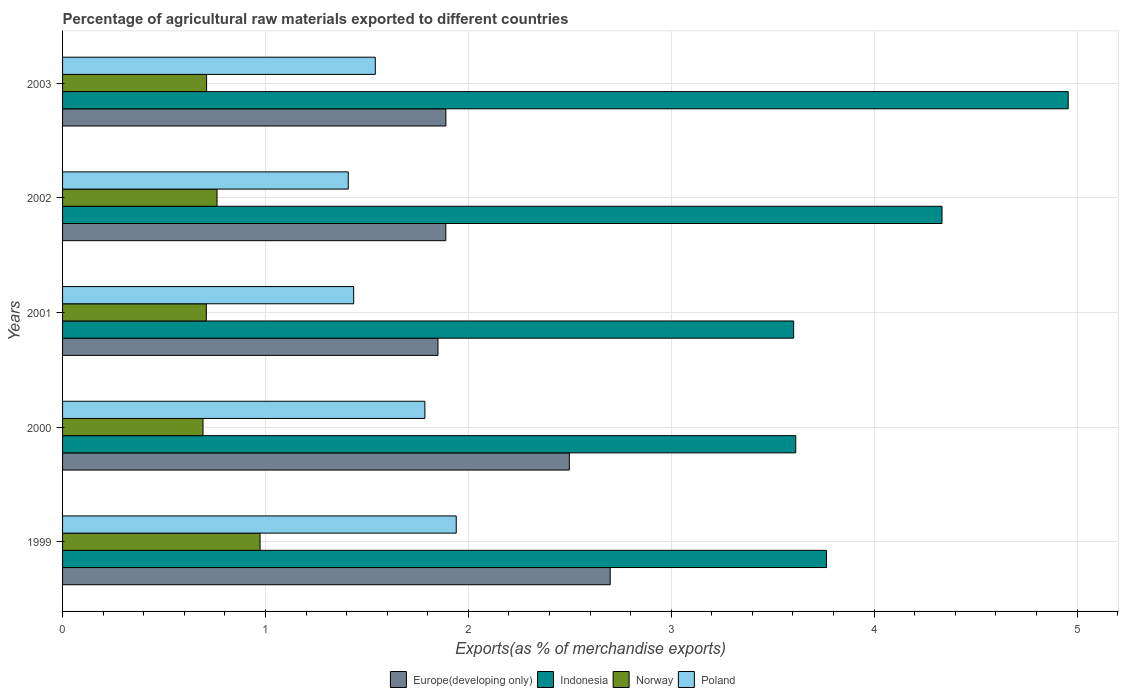How many groups of bars are there?
Give a very brief answer. 5. Are the number of bars per tick equal to the number of legend labels?
Offer a very short reply. Yes. Are the number of bars on each tick of the Y-axis equal?
Make the answer very short. Yes. How many bars are there on the 2nd tick from the top?
Your answer should be very brief. 4. What is the percentage of exports to different countries in Indonesia in 1999?
Offer a very short reply. 3.77. Across all years, what is the maximum percentage of exports to different countries in Norway?
Keep it short and to the point. 0.97. Across all years, what is the minimum percentage of exports to different countries in Poland?
Provide a succinct answer. 1.41. In which year was the percentage of exports to different countries in Indonesia maximum?
Provide a short and direct response. 2003. What is the total percentage of exports to different countries in Indonesia in the graph?
Offer a terse response. 20.27. What is the difference between the percentage of exports to different countries in Norway in 2000 and that in 2003?
Keep it short and to the point. -0.02. What is the difference between the percentage of exports to different countries in Poland in 2003 and the percentage of exports to different countries in Europe(developing only) in 2002?
Provide a short and direct response. -0.35. What is the average percentage of exports to different countries in Poland per year?
Your answer should be compact. 1.62. In the year 1999, what is the difference between the percentage of exports to different countries in Indonesia and percentage of exports to different countries in Poland?
Your answer should be very brief. 1.83. In how many years, is the percentage of exports to different countries in Indonesia greater than 3.2 %?
Offer a terse response. 5. What is the ratio of the percentage of exports to different countries in Norway in 2001 to that in 2003?
Your response must be concise. 1. Is the percentage of exports to different countries in Europe(developing only) in 2001 less than that in 2003?
Provide a succinct answer. Yes. Is the difference between the percentage of exports to different countries in Indonesia in 1999 and 2000 greater than the difference between the percentage of exports to different countries in Poland in 1999 and 2000?
Provide a short and direct response. No. What is the difference between the highest and the second highest percentage of exports to different countries in Europe(developing only)?
Keep it short and to the point. 0.2. What is the difference between the highest and the lowest percentage of exports to different countries in Poland?
Your response must be concise. 0.53. Is the sum of the percentage of exports to different countries in Norway in 2001 and 2002 greater than the maximum percentage of exports to different countries in Indonesia across all years?
Provide a succinct answer. No. Is it the case that in every year, the sum of the percentage of exports to different countries in Norway and percentage of exports to different countries in Europe(developing only) is greater than the sum of percentage of exports to different countries in Indonesia and percentage of exports to different countries in Poland?
Offer a very short reply. No. What does the 3rd bar from the top in 2002 represents?
Your answer should be very brief. Indonesia. How many bars are there?
Provide a succinct answer. 20. Does the graph contain grids?
Your answer should be very brief. Yes. What is the title of the graph?
Your answer should be compact. Percentage of agricultural raw materials exported to different countries. What is the label or title of the X-axis?
Your response must be concise. Exports(as % of merchandise exports). What is the Exports(as % of merchandise exports) in Europe(developing only) in 1999?
Offer a very short reply. 2.7. What is the Exports(as % of merchandise exports) of Indonesia in 1999?
Offer a terse response. 3.77. What is the Exports(as % of merchandise exports) of Norway in 1999?
Keep it short and to the point. 0.97. What is the Exports(as % of merchandise exports) of Poland in 1999?
Keep it short and to the point. 1.94. What is the Exports(as % of merchandise exports) in Europe(developing only) in 2000?
Offer a terse response. 2.5. What is the Exports(as % of merchandise exports) in Indonesia in 2000?
Offer a terse response. 3.61. What is the Exports(as % of merchandise exports) in Norway in 2000?
Give a very brief answer. 0.69. What is the Exports(as % of merchandise exports) of Poland in 2000?
Your answer should be compact. 1.79. What is the Exports(as % of merchandise exports) of Europe(developing only) in 2001?
Keep it short and to the point. 1.85. What is the Exports(as % of merchandise exports) in Indonesia in 2001?
Your answer should be very brief. 3.6. What is the Exports(as % of merchandise exports) of Norway in 2001?
Your answer should be compact. 0.71. What is the Exports(as % of merchandise exports) of Poland in 2001?
Your answer should be very brief. 1.43. What is the Exports(as % of merchandise exports) of Europe(developing only) in 2002?
Keep it short and to the point. 1.89. What is the Exports(as % of merchandise exports) in Indonesia in 2002?
Provide a succinct answer. 4.33. What is the Exports(as % of merchandise exports) of Norway in 2002?
Provide a short and direct response. 0.76. What is the Exports(as % of merchandise exports) of Poland in 2002?
Offer a very short reply. 1.41. What is the Exports(as % of merchandise exports) in Europe(developing only) in 2003?
Your answer should be compact. 1.89. What is the Exports(as % of merchandise exports) in Indonesia in 2003?
Keep it short and to the point. 4.96. What is the Exports(as % of merchandise exports) of Norway in 2003?
Ensure brevity in your answer.  0.71. What is the Exports(as % of merchandise exports) of Poland in 2003?
Offer a terse response. 1.54. Across all years, what is the maximum Exports(as % of merchandise exports) of Europe(developing only)?
Keep it short and to the point. 2.7. Across all years, what is the maximum Exports(as % of merchandise exports) in Indonesia?
Provide a short and direct response. 4.96. Across all years, what is the maximum Exports(as % of merchandise exports) of Norway?
Ensure brevity in your answer.  0.97. Across all years, what is the maximum Exports(as % of merchandise exports) in Poland?
Offer a very short reply. 1.94. Across all years, what is the minimum Exports(as % of merchandise exports) in Europe(developing only)?
Your answer should be compact. 1.85. Across all years, what is the minimum Exports(as % of merchandise exports) in Indonesia?
Offer a terse response. 3.6. Across all years, what is the minimum Exports(as % of merchandise exports) in Norway?
Offer a terse response. 0.69. Across all years, what is the minimum Exports(as % of merchandise exports) of Poland?
Give a very brief answer. 1.41. What is the total Exports(as % of merchandise exports) of Europe(developing only) in the graph?
Offer a terse response. 10.83. What is the total Exports(as % of merchandise exports) in Indonesia in the graph?
Keep it short and to the point. 20.27. What is the total Exports(as % of merchandise exports) in Norway in the graph?
Make the answer very short. 3.85. What is the total Exports(as % of merchandise exports) in Poland in the graph?
Provide a succinct answer. 8.11. What is the difference between the Exports(as % of merchandise exports) in Europe(developing only) in 1999 and that in 2000?
Provide a short and direct response. 0.2. What is the difference between the Exports(as % of merchandise exports) of Indonesia in 1999 and that in 2000?
Offer a terse response. 0.15. What is the difference between the Exports(as % of merchandise exports) of Norway in 1999 and that in 2000?
Ensure brevity in your answer.  0.28. What is the difference between the Exports(as % of merchandise exports) of Poland in 1999 and that in 2000?
Provide a succinct answer. 0.15. What is the difference between the Exports(as % of merchandise exports) in Europe(developing only) in 1999 and that in 2001?
Ensure brevity in your answer.  0.85. What is the difference between the Exports(as % of merchandise exports) in Indonesia in 1999 and that in 2001?
Provide a short and direct response. 0.16. What is the difference between the Exports(as % of merchandise exports) in Norway in 1999 and that in 2001?
Your answer should be very brief. 0.26. What is the difference between the Exports(as % of merchandise exports) in Poland in 1999 and that in 2001?
Give a very brief answer. 0.51. What is the difference between the Exports(as % of merchandise exports) in Europe(developing only) in 1999 and that in 2002?
Offer a very short reply. 0.81. What is the difference between the Exports(as % of merchandise exports) of Indonesia in 1999 and that in 2002?
Provide a succinct answer. -0.57. What is the difference between the Exports(as % of merchandise exports) in Norway in 1999 and that in 2002?
Your answer should be very brief. 0.21. What is the difference between the Exports(as % of merchandise exports) in Poland in 1999 and that in 2002?
Give a very brief answer. 0.53. What is the difference between the Exports(as % of merchandise exports) in Europe(developing only) in 1999 and that in 2003?
Your answer should be compact. 0.81. What is the difference between the Exports(as % of merchandise exports) in Indonesia in 1999 and that in 2003?
Your answer should be compact. -1.19. What is the difference between the Exports(as % of merchandise exports) of Norway in 1999 and that in 2003?
Give a very brief answer. 0.26. What is the difference between the Exports(as % of merchandise exports) of Poland in 1999 and that in 2003?
Ensure brevity in your answer.  0.4. What is the difference between the Exports(as % of merchandise exports) of Europe(developing only) in 2000 and that in 2001?
Ensure brevity in your answer.  0.65. What is the difference between the Exports(as % of merchandise exports) of Indonesia in 2000 and that in 2001?
Make the answer very short. 0.01. What is the difference between the Exports(as % of merchandise exports) of Norway in 2000 and that in 2001?
Ensure brevity in your answer.  -0.02. What is the difference between the Exports(as % of merchandise exports) of Poland in 2000 and that in 2001?
Provide a succinct answer. 0.35. What is the difference between the Exports(as % of merchandise exports) of Europe(developing only) in 2000 and that in 2002?
Make the answer very short. 0.61. What is the difference between the Exports(as % of merchandise exports) in Indonesia in 2000 and that in 2002?
Your response must be concise. -0.72. What is the difference between the Exports(as % of merchandise exports) in Norway in 2000 and that in 2002?
Ensure brevity in your answer.  -0.07. What is the difference between the Exports(as % of merchandise exports) of Poland in 2000 and that in 2002?
Keep it short and to the point. 0.38. What is the difference between the Exports(as % of merchandise exports) in Europe(developing only) in 2000 and that in 2003?
Your answer should be very brief. 0.61. What is the difference between the Exports(as % of merchandise exports) in Indonesia in 2000 and that in 2003?
Your answer should be very brief. -1.34. What is the difference between the Exports(as % of merchandise exports) in Norway in 2000 and that in 2003?
Make the answer very short. -0.02. What is the difference between the Exports(as % of merchandise exports) of Poland in 2000 and that in 2003?
Your answer should be very brief. 0.24. What is the difference between the Exports(as % of merchandise exports) of Europe(developing only) in 2001 and that in 2002?
Ensure brevity in your answer.  -0.04. What is the difference between the Exports(as % of merchandise exports) of Indonesia in 2001 and that in 2002?
Provide a succinct answer. -0.73. What is the difference between the Exports(as % of merchandise exports) of Norway in 2001 and that in 2002?
Keep it short and to the point. -0.05. What is the difference between the Exports(as % of merchandise exports) in Poland in 2001 and that in 2002?
Your answer should be compact. 0.03. What is the difference between the Exports(as % of merchandise exports) in Europe(developing only) in 2001 and that in 2003?
Offer a very short reply. -0.04. What is the difference between the Exports(as % of merchandise exports) of Indonesia in 2001 and that in 2003?
Give a very brief answer. -1.35. What is the difference between the Exports(as % of merchandise exports) in Norway in 2001 and that in 2003?
Offer a terse response. -0. What is the difference between the Exports(as % of merchandise exports) of Poland in 2001 and that in 2003?
Provide a short and direct response. -0.11. What is the difference between the Exports(as % of merchandise exports) in Europe(developing only) in 2002 and that in 2003?
Keep it short and to the point. -0. What is the difference between the Exports(as % of merchandise exports) in Indonesia in 2002 and that in 2003?
Provide a short and direct response. -0.62. What is the difference between the Exports(as % of merchandise exports) of Norway in 2002 and that in 2003?
Make the answer very short. 0.05. What is the difference between the Exports(as % of merchandise exports) of Poland in 2002 and that in 2003?
Provide a short and direct response. -0.13. What is the difference between the Exports(as % of merchandise exports) of Europe(developing only) in 1999 and the Exports(as % of merchandise exports) of Indonesia in 2000?
Offer a very short reply. -0.91. What is the difference between the Exports(as % of merchandise exports) in Europe(developing only) in 1999 and the Exports(as % of merchandise exports) in Norway in 2000?
Your answer should be compact. 2.01. What is the difference between the Exports(as % of merchandise exports) in Europe(developing only) in 1999 and the Exports(as % of merchandise exports) in Poland in 2000?
Your answer should be very brief. 0.91. What is the difference between the Exports(as % of merchandise exports) of Indonesia in 1999 and the Exports(as % of merchandise exports) of Norway in 2000?
Your answer should be very brief. 3.07. What is the difference between the Exports(as % of merchandise exports) of Indonesia in 1999 and the Exports(as % of merchandise exports) of Poland in 2000?
Provide a succinct answer. 1.98. What is the difference between the Exports(as % of merchandise exports) in Norway in 1999 and the Exports(as % of merchandise exports) in Poland in 2000?
Make the answer very short. -0.81. What is the difference between the Exports(as % of merchandise exports) of Europe(developing only) in 1999 and the Exports(as % of merchandise exports) of Indonesia in 2001?
Your answer should be very brief. -0.9. What is the difference between the Exports(as % of merchandise exports) in Europe(developing only) in 1999 and the Exports(as % of merchandise exports) in Norway in 2001?
Provide a short and direct response. 1.99. What is the difference between the Exports(as % of merchandise exports) in Europe(developing only) in 1999 and the Exports(as % of merchandise exports) in Poland in 2001?
Make the answer very short. 1.26. What is the difference between the Exports(as % of merchandise exports) in Indonesia in 1999 and the Exports(as % of merchandise exports) in Norway in 2001?
Keep it short and to the point. 3.06. What is the difference between the Exports(as % of merchandise exports) in Indonesia in 1999 and the Exports(as % of merchandise exports) in Poland in 2001?
Keep it short and to the point. 2.33. What is the difference between the Exports(as % of merchandise exports) of Norway in 1999 and the Exports(as % of merchandise exports) of Poland in 2001?
Your response must be concise. -0.46. What is the difference between the Exports(as % of merchandise exports) in Europe(developing only) in 1999 and the Exports(as % of merchandise exports) in Indonesia in 2002?
Your answer should be very brief. -1.64. What is the difference between the Exports(as % of merchandise exports) of Europe(developing only) in 1999 and the Exports(as % of merchandise exports) of Norway in 2002?
Provide a succinct answer. 1.94. What is the difference between the Exports(as % of merchandise exports) in Europe(developing only) in 1999 and the Exports(as % of merchandise exports) in Poland in 2002?
Your answer should be very brief. 1.29. What is the difference between the Exports(as % of merchandise exports) in Indonesia in 1999 and the Exports(as % of merchandise exports) in Norway in 2002?
Keep it short and to the point. 3. What is the difference between the Exports(as % of merchandise exports) of Indonesia in 1999 and the Exports(as % of merchandise exports) of Poland in 2002?
Ensure brevity in your answer.  2.36. What is the difference between the Exports(as % of merchandise exports) in Norway in 1999 and the Exports(as % of merchandise exports) in Poland in 2002?
Your response must be concise. -0.43. What is the difference between the Exports(as % of merchandise exports) in Europe(developing only) in 1999 and the Exports(as % of merchandise exports) in Indonesia in 2003?
Offer a very short reply. -2.26. What is the difference between the Exports(as % of merchandise exports) in Europe(developing only) in 1999 and the Exports(as % of merchandise exports) in Norway in 2003?
Your answer should be very brief. 1.99. What is the difference between the Exports(as % of merchandise exports) in Europe(developing only) in 1999 and the Exports(as % of merchandise exports) in Poland in 2003?
Keep it short and to the point. 1.16. What is the difference between the Exports(as % of merchandise exports) of Indonesia in 1999 and the Exports(as % of merchandise exports) of Norway in 2003?
Ensure brevity in your answer.  3.06. What is the difference between the Exports(as % of merchandise exports) in Indonesia in 1999 and the Exports(as % of merchandise exports) in Poland in 2003?
Ensure brevity in your answer.  2.22. What is the difference between the Exports(as % of merchandise exports) of Norway in 1999 and the Exports(as % of merchandise exports) of Poland in 2003?
Provide a succinct answer. -0.57. What is the difference between the Exports(as % of merchandise exports) of Europe(developing only) in 2000 and the Exports(as % of merchandise exports) of Indonesia in 2001?
Provide a short and direct response. -1.11. What is the difference between the Exports(as % of merchandise exports) of Europe(developing only) in 2000 and the Exports(as % of merchandise exports) of Norway in 2001?
Provide a succinct answer. 1.79. What is the difference between the Exports(as % of merchandise exports) in Europe(developing only) in 2000 and the Exports(as % of merchandise exports) in Poland in 2001?
Provide a succinct answer. 1.06. What is the difference between the Exports(as % of merchandise exports) of Indonesia in 2000 and the Exports(as % of merchandise exports) of Norway in 2001?
Provide a succinct answer. 2.91. What is the difference between the Exports(as % of merchandise exports) in Indonesia in 2000 and the Exports(as % of merchandise exports) in Poland in 2001?
Make the answer very short. 2.18. What is the difference between the Exports(as % of merchandise exports) of Norway in 2000 and the Exports(as % of merchandise exports) of Poland in 2001?
Provide a succinct answer. -0.74. What is the difference between the Exports(as % of merchandise exports) in Europe(developing only) in 2000 and the Exports(as % of merchandise exports) in Indonesia in 2002?
Give a very brief answer. -1.84. What is the difference between the Exports(as % of merchandise exports) in Europe(developing only) in 2000 and the Exports(as % of merchandise exports) in Norway in 2002?
Provide a succinct answer. 1.74. What is the difference between the Exports(as % of merchandise exports) in Europe(developing only) in 2000 and the Exports(as % of merchandise exports) in Poland in 2002?
Offer a very short reply. 1.09. What is the difference between the Exports(as % of merchandise exports) in Indonesia in 2000 and the Exports(as % of merchandise exports) in Norway in 2002?
Make the answer very short. 2.85. What is the difference between the Exports(as % of merchandise exports) in Indonesia in 2000 and the Exports(as % of merchandise exports) in Poland in 2002?
Provide a succinct answer. 2.21. What is the difference between the Exports(as % of merchandise exports) in Norway in 2000 and the Exports(as % of merchandise exports) in Poland in 2002?
Provide a succinct answer. -0.72. What is the difference between the Exports(as % of merchandise exports) of Europe(developing only) in 2000 and the Exports(as % of merchandise exports) of Indonesia in 2003?
Offer a terse response. -2.46. What is the difference between the Exports(as % of merchandise exports) of Europe(developing only) in 2000 and the Exports(as % of merchandise exports) of Norway in 2003?
Your answer should be compact. 1.79. What is the difference between the Exports(as % of merchandise exports) in Europe(developing only) in 2000 and the Exports(as % of merchandise exports) in Poland in 2003?
Keep it short and to the point. 0.96. What is the difference between the Exports(as % of merchandise exports) in Indonesia in 2000 and the Exports(as % of merchandise exports) in Norway in 2003?
Give a very brief answer. 2.9. What is the difference between the Exports(as % of merchandise exports) in Indonesia in 2000 and the Exports(as % of merchandise exports) in Poland in 2003?
Provide a succinct answer. 2.07. What is the difference between the Exports(as % of merchandise exports) of Norway in 2000 and the Exports(as % of merchandise exports) of Poland in 2003?
Your response must be concise. -0.85. What is the difference between the Exports(as % of merchandise exports) of Europe(developing only) in 2001 and the Exports(as % of merchandise exports) of Indonesia in 2002?
Your response must be concise. -2.48. What is the difference between the Exports(as % of merchandise exports) in Europe(developing only) in 2001 and the Exports(as % of merchandise exports) in Norway in 2002?
Your answer should be compact. 1.09. What is the difference between the Exports(as % of merchandise exports) in Europe(developing only) in 2001 and the Exports(as % of merchandise exports) in Poland in 2002?
Keep it short and to the point. 0.44. What is the difference between the Exports(as % of merchandise exports) in Indonesia in 2001 and the Exports(as % of merchandise exports) in Norway in 2002?
Your answer should be very brief. 2.84. What is the difference between the Exports(as % of merchandise exports) in Indonesia in 2001 and the Exports(as % of merchandise exports) in Poland in 2002?
Provide a short and direct response. 2.2. What is the difference between the Exports(as % of merchandise exports) of Norway in 2001 and the Exports(as % of merchandise exports) of Poland in 2002?
Keep it short and to the point. -0.7. What is the difference between the Exports(as % of merchandise exports) in Europe(developing only) in 2001 and the Exports(as % of merchandise exports) in Indonesia in 2003?
Offer a terse response. -3.11. What is the difference between the Exports(as % of merchandise exports) in Europe(developing only) in 2001 and the Exports(as % of merchandise exports) in Norway in 2003?
Provide a short and direct response. 1.14. What is the difference between the Exports(as % of merchandise exports) of Europe(developing only) in 2001 and the Exports(as % of merchandise exports) of Poland in 2003?
Your answer should be very brief. 0.31. What is the difference between the Exports(as % of merchandise exports) of Indonesia in 2001 and the Exports(as % of merchandise exports) of Norway in 2003?
Your answer should be compact. 2.89. What is the difference between the Exports(as % of merchandise exports) of Indonesia in 2001 and the Exports(as % of merchandise exports) of Poland in 2003?
Provide a succinct answer. 2.06. What is the difference between the Exports(as % of merchandise exports) in Norway in 2001 and the Exports(as % of merchandise exports) in Poland in 2003?
Provide a short and direct response. -0.83. What is the difference between the Exports(as % of merchandise exports) of Europe(developing only) in 2002 and the Exports(as % of merchandise exports) of Indonesia in 2003?
Provide a short and direct response. -3.07. What is the difference between the Exports(as % of merchandise exports) in Europe(developing only) in 2002 and the Exports(as % of merchandise exports) in Norway in 2003?
Make the answer very short. 1.18. What is the difference between the Exports(as % of merchandise exports) of Europe(developing only) in 2002 and the Exports(as % of merchandise exports) of Poland in 2003?
Keep it short and to the point. 0.35. What is the difference between the Exports(as % of merchandise exports) in Indonesia in 2002 and the Exports(as % of merchandise exports) in Norway in 2003?
Your response must be concise. 3.62. What is the difference between the Exports(as % of merchandise exports) in Indonesia in 2002 and the Exports(as % of merchandise exports) in Poland in 2003?
Offer a terse response. 2.79. What is the difference between the Exports(as % of merchandise exports) in Norway in 2002 and the Exports(as % of merchandise exports) in Poland in 2003?
Keep it short and to the point. -0.78. What is the average Exports(as % of merchandise exports) of Europe(developing only) per year?
Your answer should be compact. 2.17. What is the average Exports(as % of merchandise exports) of Indonesia per year?
Give a very brief answer. 4.05. What is the average Exports(as % of merchandise exports) in Norway per year?
Give a very brief answer. 0.77. What is the average Exports(as % of merchandise exports) of Poland per year?
Offer a terse response. 1.62. In the year 1999, what is the difference between the Exports(as % of merchandise exports) in Europe(developing only) and Exports(as % of merchandise exports) in Indonesia?
Make the answer very short. -1.07. In the year 1999, what is the difference between the Exports(as % of merchandise exports) of Europe(developing only) and Exports(as % of merchandise exports) of Norway?
Your answer should be compact. 1.73. In the year 1999, what is the difference between the Exports(as % of merchandise exports) in Europe(developing only) and Exports(as % of merchandise exports) in Poland?
Give a very brief answer. 0.76. In the year 1999, what is the difference between the Exports(as % of merchandise exports) in Indonesia and Exports(as % of merchandise exports) in Norway?
Provide a short and direct response. 2.79. In the year 1999, what is the difference between the Exports(as % of merchandise exports) in Indonesia and Exports(as % of merchandise exports) in Poland?
Keep it short and to the point. 1.83. In the year 1999, what is the difference between the Exports(as % of merchandise exports) in Norway and Exports(as % of merchandise exports) in Poland?
Offer a very short reply. -0.97. In the year 2000, what is the difference between the Exports(as % of merchandise exports) in Europe(developing only) and Exports(as % of merchandise exports) in Indonesia?
Provide a short and direct response. -1.12. In the year 2000, what is the difference between the Exports(as % of merchandise exports) in Europe(developing only) and Exports(as % of merchandise exports) in Norway?
Keep it short and to the point. 1.81. In the year 2000, what is the difference between the Exports(as % of merchandise exports) in Europe(developing only) and Exports(as % of merchandise exports) in Poland?
Provide a succinct answer. 0.71. In the year 2000, what is the difference between the Exports(as % of merchandise exports) in Indonesia and Exports(as % of merchandise exports) in Norway?
Provide a short and direct response. 2.92. In the year 2000, what is the difference between the Exports(as % of merchandise exports) of Indonesia and Exports(as % of merchandise exports) of Poland?
Make the answer very short. 1.83. In the year 2000, what is the difference between the Exports(as % of merchandise exports) of Norway and Exports(as % of merchandise exports) of Poland?
Your answer should be compact. -1.09. In the year 2001, what is the difference between the Exports(as % of merchandise exports) in Europe(developing only) and Exports(as % of merchandise exports) in Indonesia?
Keep it short and to the point. -1.75. In the year 2001, what is the difference between the Exports(as % of merchandise exports) of Europe(developing only) and Exports(as % of merchandise exports) of Norway?
Offer a very short reply. 1.14. In the year 2001, what is the difference between the Exports(as % of merchandise exports) in Europe(developing only) and Exports(as % of merchandise exports) in Poland?
Your answer should be very brief. 0.42. In the year 2001, what is the difference between the Exports(as % of merchandise exports) in Indonesia and Exports(as % of merchandise exports) in Norway?
Keep it short and to the point. 2.89. In the year 2001, what is the difference between the Exports(as % of merchandise exports) in Indonesia and Exports(as % of merchandise exports) in Poland?
Ensure brevity in your answer.  2.17. In the year 2001, what is the difference between the Exports(as % of merchandise exports) of Norway and Exports(as % of merchandise exports) of Poland?
Give a very brief answer. -0.73. In the year 2002, what is the difference between the Exports(as % of merchandise exports) of Europe(developing only) and Exports(as % of merchandise exports) of Indonesia?
Your response must be concise. -2.45. In the year 2002, what is the difference between the Exports(as % of merchandise exports) of Europe(developing only) and Exports(as % of merchandise exports) of Norway?
Give a very brief answer. 1.13. In the year 2002, what is the difference between the Exports(as % of merchandise exports) in Europe(developing only) and Exports(as % of merchandise exports) in Poland?
Give a very brief answer. 0.48. In the year 2002, what is the difference between the Exports(as % of merchandise exports) in Indonesia and Exports(as % of merchandise exports) in Norway?
Offer a terse response. 3.57. In the year 2002, what is the difference between the Exports(as % of merchandise exports) in Indonesia and Exports(as % of merchandise exports) in Poland?
Your answer should be very brief. 2.93. In the year 2002, what is the difference between the Exports(as % of merchandise exports) of Norway and Exports(as % of merchandise exports) of Poland?
Your answer should be compact. -0.65. In the year 2003, what is the difference between the Exports(as % of merchandise exports) in Europe(developing only) and Exports(as % of merchandise exports) in Indonesia?
Give a very brief answer. -3.07. In the year 2003, what is the difference between the Exports(as % of merchandise exports) in Europe(developing only) and Exports(as % of merchandise exports) in Norway?
Offer a terse response. 1.18. In the year 2003, what is the difference between the Exports(as % of merchandise exports) in Europe(developing only) and Exports(as % of merchandise exports) in Poland?
Your answer should be compact. 0.35. In the year 2003, what is the difference between the Exports(as % of merchandise exports) in Indonesia and Exports(as % of merchandise exports) in Norway?
Provide a short and direct response. 4.25. In the year 2003, what is the difference between the Exports(as % of merchandise exports) in Indonesia and Exports(as % of merchandise exports) in Poland?
Your response must be concise. 3.42. In the year 2003, what is the difference between the Exports(as % of merchandise exports) in Norway and Exports(as % of merchandise exports) in Poland?
Offer a very short reply. -0.83. What is the ratio of the Exports(as % of merchandise exports) of Europe(developing only) in 1999 to that in 2000?
Your answer should be compact. 1.08. What is the ratio of the Exports(as % of merchandise exports) in Indonesia in 1999 to that in 2000?
Offer a terse response. 1.04. What is the ratio of the Exports(as % of merchandise exports) in Norway in 1999 to that in 2000?
Your answer should be compact. 1.41. What is the ratio of the Exports(as % of merchandise exports) of Poland in 1999 to that in 2000?
Your answer should be very brief. 1.09. What is the ratio of the Exports(as % of merchandise exports) of Europe(developing only) in 1999 to that in 2001?
Offer a very short reply. 1.46. What is the ratio of the Exports(as % of merchandise exports) in Indonesia in 1999 to that in 2001?
Give a very brief answer. 1.04. What is the ratio of the Exports(as % of merchandise exports) in Norway in 1999 to that in 2001?
Give a very brief answer. 1.37. What is the ratio of the Exports(as % of merchandise exports) of Poland in 1999 to that in 2001?
Ensure brevity in your answer.  1.35. What is the ratio of the Exports(as % of merchandise exports) in Europe(developing only) in 1999 to that in 2002?
Your answer should be compact. 1.43. What is the ratio of the Exports(as % of merchandise exports) in Indonesia in 1999 to that in 2002?
Make the answer very short. 0.87. What is the ratio of the Exports(as % of merchandise exports) in Norway in 1999 to that in 2002?
Offer a very short reply. 1.28. What is the ratio of the Exports(as % of merchandise exports) of Poland in 1999 to that in 2002?
Give a very brief answer. 1.38. What is the ratio of the Exports(as % of merchandise exports) of Europe(developing only) in 1999 to that in 2003?
Make the answer very short. 1.43. What is the ratio of the Exports(as % of merchandise exports) in Indonesia in 1999 to that in 2003?
Offer a terse response. 0.76. What is the ratio of the Exports(as % of merchandise exports) in Norway in 1999 to that in 2003?
Provide a succinct answer. 1.37. What is the ratio of the Exports(as % of merchandise exports) in Poland in 1999 to that in 2003?
Ensure brevity in your answer.  1.26. What is the ratio of the Exports(as % of merchandise exports) in Europe(developing only) in 2000 to that in 2001?
Your answer should be compact. 1.35. What is the ratio of the Exports(as % of merchandise exports) of Norway in 2000 to that in 2001?
Your answer should be compact. 0.98. What is the ratio of the Exports(as % of merchandise exports) of Poland in 2000 to that in 2001?
Keep it short and to the point. 1.24. What is the ratio of the Exports(as % of merchandise exports) in Europe(developing only) in 2000 to that in 2002?
Provide a succinct answer. 1.32. What is the ratio of the Exports(as % of merchandise exports) of Indonesia in 2000 to that in 2002?
Make the answer very short. 0.83. What is the ratio of the Exports(as % of merchandise exports) in Norway in 2000 to that in 2002?
Provide a succinct answer. 0.91. What is the ratio of the Exports(as % of merchandise exports) in Poland in 2000 to that in 2002?
Offer a very short reply. 1.27. What is the ratio of the Exports(as % of merchandise exports) of Europe(developing only) in 2000 to that in 2003?
Ensure brevity in your answer.  1.32. What is the ratio of the Exports(as % of merchandise exports) in Indonesia in 2000 to that in 2003?
Your response must be concise. 0.73. What is the ratio of the Exports(as % of merchandise exports) of Norway in 2000 to that in 2003?
Your answer should be very brief. 0.98. What is the ratio of the Exports(as % of merchandise exports) of Poland in 2000 to that in 2003?
Offer a terse response. 1.16. What is the ratio of the Exports(as % of merchandise exports) in Europe(developing only) in 2001 to that in 2002?
Provide a succinct answer. 0.98. What is the ratio of the Exports(as % of merchandise exports) of Indonesia in 2001 to that in 2002?
Provide a succinct answer. 0.83. What is the ratio of the Exports(as % of merchandise exports) of Norway in 2001 to that in 2002?
Provide a succinct answer. 0.93. What is the ratio of the Exports(as % of merchandise exports) of Poland in 2001 to that in 2002?
Give a very brief answer. 1.02. What is the ratio of the Exports(as % of merchandise exports) in Europe(developing only) in 2001 to that in 2003?
Provide a short and direct response. 0.98. What is the ratio of the Exports(as % of merchandise exports) of Indonesia in 2001 to that in 2003?
Keep it short and to the point. 0.73. What is the ratio of the Exports(as % of merchandise exports) in Norway in 2001 to that in 2003?
Provide a short and direct response. 1. What is the ratio of the Exports(as % of merchandise exports) of Poland in 2001 to that in 2003?
Your response must be concise. 0.93. What is the ratio of the Exports(as % of merchandise exports) in Indonesia in 2002 to that in 2003?
Your answer should be very brief. 0.87. What is the ratio of the Exports(as % of merchandise exports) in Norway in 2002 to that in 2003?
Your answer should be compact. 1.07. What is the ratio of the Exports(as % of merchandise exports) of Poland in 2002 to that in 2003?
Provide a succinct answer. 0.91. What is the difference between the highest and the second highest Exports(as % of merchandise exports) in Europe(developing only)?
Provide a succinct answer. 0.2. What is the difference between the highest and the second highest Exports(as % of merchandise exports) in Indonesia?
Provide a succinct answer. 0.62. What is the difference between the highest and the second highest Exports(as % of merchandise exports) of Norway?
Ensure brevity in your answer.  0.21. What is the difference between the highest and the second highest Exports(as % of merchandise exports) of Poland?
Your answer should be compact. 0.15. What is the difference between the highest and the lowest Exports(as % of merchandise exports) of Europe(developing only)?
Ensure brevity in your answer.  0.85. What is the difference between the highest and the lowest Exports(as % of merchandise exports) in Indonesia?
Your answer should be very brief. 1.35. What is the difference between the highest and the lowest Exports(as % of merchandise exports) of Norway?
Offer a very short reply. 0.28. What is the difference between the highest and the lowest Exports(as % of merchandise exports) of Poland?
Make the answer very short. 0.53. 